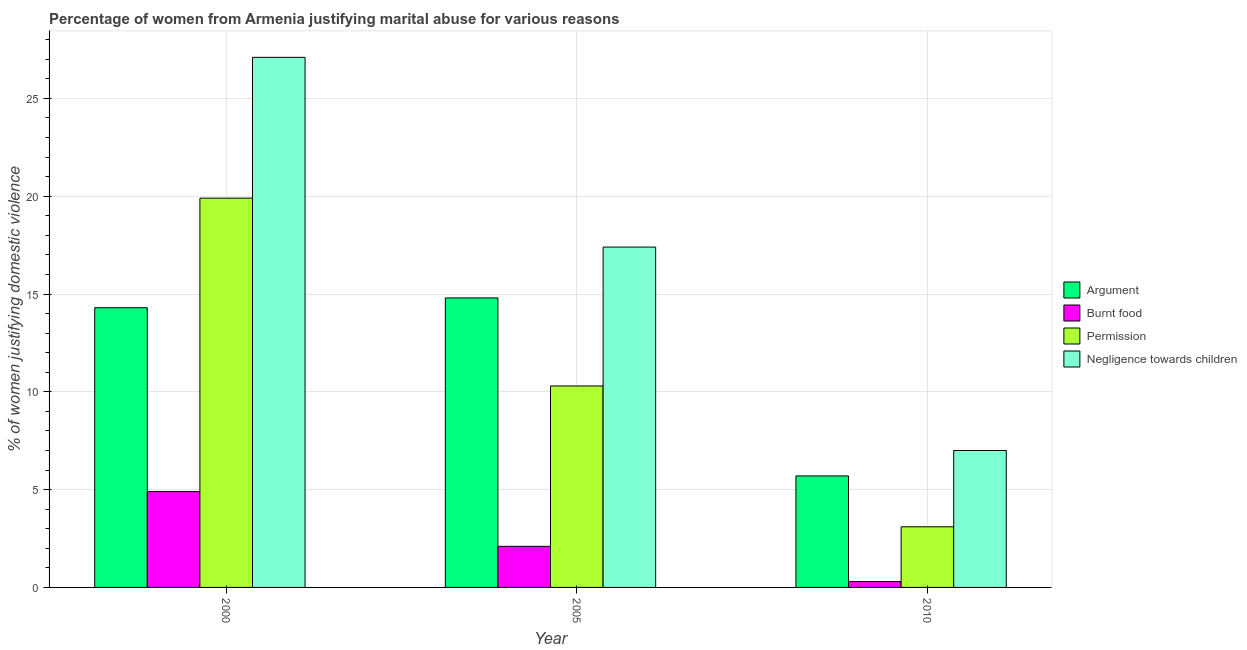How many groups of bars are there?
Your answer should be very brief. 3. Are the number of bars per tick equal to the number of legend labels?
Keep it short and to the point. Yes. Are the number of bars on each tick of the X-axis equal?
Provide a short and direct response. Yes. How many bars are there on the 3rd tick from the right?
Offer a terse response. 4. What is the label of the 3rd group of bars from the left?
Give a very brief answer. 2010. In how many cases, is the number of bars for a given year not equal to the number of legend labels?
Your answer should be compact. 0. What is the percentage of women justifying abuse for showing negligence towards children in 2000?
Your answer should be compact. 27.1. In which year was the percentage of women justifying abuse for burning food maximum?
Ensure brevity in your answer.  2000. What is the total percentage of women justifying abuse for burning food in the graph?
Ensure brevity in your answer.  7.3. What is the difference between the percentage of women justifying abuse for showing negligence towards children in 2005 and that in 2010?
Your answer should be very brief. 10.4. What is the difference between the percentage of women justifying abuse for showing negligence towards children in 2010 and the percentage of women justifying abuse for going without permission in 2000?
Offer a terse response. -20.1. What is the ratio of the percentage of women justifying abuse in the case of an argument in 2000 to that in 2010?
Offer a very short reply. 2.51. Is the percentage of women justifying abuse for burning food in 2005 less than that in 2010?
Offer a very short reply. No. Is the difference between the percentage of women justifying abuse for going without permission in 2000 and 2010 greater than the difference between the percentage of women justifying abuse in the case of an argument in 2000 and 2010?
Offer a very short reply. No. What is the difference between the highest and the second highest percentage of women justifying abuse for showing negligence towards children?
Give a very brief answer. 9.7. What is the difference between the highest and the lowest percentage of women justifying abuse in the case of an argument?
Give a very brief answer. 9.1. Is the sum of the percentage of women justifying abuse for burning food in 2000 and 2010 greater than the maximum percentage of women justifying abuse in the case of an argument across all years?
Offer a very short reply. Yes. What does the 4th bar from the left in 2010 represents?
Offer a very short reply. Negligence towards children. What does the 4th bar from the right in 2005 represents?
Give a very brief answer. Argument. How many bars are there?
Your answer should be very brief. 12. What is the difference between two consecutive major ticks on the Y-axis?
Offer a very short reply. 5. Where does the legend appear in the graph?
Offer a very short reply. Center right. How many legend labels are there?
Your answer should be very brief. 4. How are the legend labels stacked?
Your answer should be compact. Vertical. What is the title of the graph?
Keep it short and to the point. Percentage of women from Armenia justifying marital abuse for various reasons. What is the label or title of the Y-axis?
Offer a very short reply. % of women justifying domestic violence. What is the % of women justifying domestic violence of Permission in 2000?
Keep it short and to the point. 19.9. What is the % of women justifying domestic violence of Negligence towards children in 2000?
Provide a short and direct response. 27.1. What is the % of women justifying domestic violence in Permission in 2005?
Give a very brief answer. 10.3. What is the % of women justifying domestic violence in Negligence towards children in 2005?
Provide a succinct answer. 17.4. What is the % of women justifying domestic violence in Argument in 2010?
Your answer should be compact. 5.7. What is the % of women justifying domestic violence of Negligence towards children in 2010?
Provide a short and direct response. 7. Across all years, what is the maximum % of women justifying domestic violence of Argument?
Provide a short and direct response. 14.8. Across all years, what is the maximum % of women justifying domestic violence of Burnt food?
Keep it short and to the point. 4.9. Across all years, what is the maximum % of women justifying domestic violence in Permission?
Your answer should be very brief. 19.9. Across all years, what is the maximum % of women justifying domestic violence of Negligence towards children?
Provide a succinct answer. 27.1. Across all years, what is the minimum % of women justifying domestic violence in Negligence towards children?
Offer a very short reply. 7. What is the total % of women justifying domestic violence of Argument in the graph?
Make the answer very short. 34.8. What is the total % of women justifying domestic violence of Permission in the graph?
Your answer should be very brief. 33.3. What is the total % of women justifying domestic violence in Negligence towards children in the graph?
Offer a very short reply. 51.5. What is the difference between the % of women justifying domestic violence in Burnt food in 2000 and that in 2005?
Give a very brief answer. 2.8. What is the difference between the % of women justifying domestic violence in Negligence towards children in 2000 and that in 2005?
Ensure brevity in your answer.  9.7. What is the difference between the % of women justifying domestic violence of Permission in 2000 and that in 2010?
Offer a terse response. 16.8. What is the difference between the % of women justifying domestic violence of Negligence towards children in 2000 and that in 2010?
Offer a terse response. 20.1. What is the difference between the % of women justifying domestic violence of Argument in 2005 and that in 2010?
Offer a terse response. 9.1. What is the difference between the % of women justifying domestic violence in Negligence towards children in 2005 and that in 2010?
Provide a succinct answer. 10.4. What is the difference between the % of women justifying domestic violence of Argument in 2000 and the % of women justifying domestic violence of Negligence towards children in 2005?
Your answer should be very brief. -3.1. What is the difference between the % of women justifying domestic violence in Burnt food in 2000 and the % of women justifying domestic violence in Negligence towards children in 2005?
Give a very brief answer. -12.5. What is the difference between the % of women justifying domestic violence of Argument in 2000 and the % of women justifying domestic violence of Burnt food in 2010?
Make the answer very short. 14. What is the difference between the % of women justifying domestic violence in Burnt food in 2000 and the % of women justifying domestic violence in Permission in 2010?
Provide a short and direct response. 1.8. What is the difference between the % of women justifying domestic violence in Argument in 2005 and the % of women justifying domestic violence in Permission in 2010?
Ensure brevity in your answer.  11.7. What is the difference between the % of women justifying domestic violence in Argument in 2005 and the % of women justifying domestic violence in Negligence towards children in 2010?
Your answer should be compact. 7.8. What is the difference between the % of women justifying domestic violence of Burnt food in 2005 and the % of women justifying domestic violence of Negligence towards children in 2010?
Make the answer very short. -4.9. What is the average % of women justifying domestic violence of Burnt food per year?
Keep it short and to the point. 2.43. What is the average % of women justifying domestic violence of Negligence towards children per year?
Your response must be concise. 17.17. In the year 2000, what is the difference between the % of women justifying domestic violence of Argument and % of women justifying domestic violence of Burnt food?
Provide a succinct answer. 9.4. In the year 2000, what is the difference between the % of women justifying domestic violence of Argument and % of women justifying domestic violence of Permission?
Your answer should be very brief. -5.6. In the year 2000, what is the difference between the % of women justifying domestic violence of Argument and % of women justifying domestic violence of Negligence towards children?
Ensure brevity in your answer.  -12.8. In the year 2000, what is the difference between the % of women justifying domestic violence in Burnt food and % of women justifying domestic violence in Permission?
Offer a very short reply. -15. In the year 2000, what is the difference between the % of women justifying domestic violence of Burnt food and % of women justifying domestic violence of Negligence towards children?
Your answer should be compact. -22.2. In the year 2005, what is the difference between the % of women justifying domestic violence of Argument and % of women justifying domestic violence of Burnt food?
Ensure brevity in your answer.  12.7. In the year 2005, what is the difference between the % of women justifying domestic violence in Argument and % of women justifying domestic violence in Permission?
Make the answer very short. 4.5. In the year 2005, what is the difference between the % of women justifying domestic violence of Argument and % of women justifying domestic violence of Negligence towards children?
Offer a very short reply. -2.6. In the year 2005, what is the difference between the % of women justifying domestic violence of Burnt food and % of women justifying domestic violence of Permission?
Provide a succinct answer. -8.2. In the year 2005, what is the difference between the % of women justifying domestic violence in Burnt food and % of women justifying domestic violence in Negligence towards children?
Offer a very short reply. -15.3. In the year 2005, what is the difference between the % of women justifying domestic violence of Permission and % of women justifying domestic violence of Negligence towards children?
Your answer should be very brief. -7.1. In the year 2010, what is the difference between the % of women justifying domestic violence in Argument and % of women justifying domestic violence in Burnt food?
Provide a succinct answer. 5.4. In the year 2010, what is the difference between the % of women justifying domestic violence in Argument and % of women justifying domestic violence in Permission?
Give a very brief answer. 2.6. In the year 2010, what is the difference between the % of women justifying domestic violence of Argument and % of women justifying domestic violence of Negligence towards children?
Make the answer very short. -1.3. In the year 2010, what is the difference between the % of women justifying domestic violence in Burnt food and % of women justifying domestic violence in Permission?
Ensure brevity in your answer.  -2.8. What is the ratio of the % of women justifying domestic violence of Argument in 2000 to that in 2005?
Offer a very short reply. 0.97. What is the ratio of the % of women justifying domestic violence in Burnt food in 2000 to that in 2005?
Your answer should be compact. 2.33. What is the ratio of the % of women justifying domestic violence in Permission in 2000 to that in 2005?
Your answer should be very brief. 1.93. What is the ratio of the % of women justifying domestic violence of Negligence towards children in 2000 to that in 2005?
Your answer should be compact. 1.56. What is the ratio of the % of women justifying domestic violence in Argument in 2000 to that in 2010?
Ensure brevity in your answer.  2.51. What is the ratio of the % of women justifying domestic violence of Burnt food in 2000 to that in 2010?
Ensure brevity in your answer.  16.33. What is the ratio of the % of women justifying domestic violence in Permission in 2000 to that in 2010?
Make the answer very short. 6.42. What is the ratio of the % of women justifying domestic violence in Negligence towards children in 2000 to that in 2010?
Offer a very short reply. 3.87. What is the ratio of the % of women justifying domestic violence in Argument in 2005 to that in 2010?
Your answer should be very brief. 2.6. What is the ratio of the % of women justifying domestic violence of Permission in 2005 to that in 2010?
Offer a very short reply. 3.32. What is the ratio of the % of women justifying domestic violence of Negligence towards children in 2005 to that in 2010?
Your answer should be very brief. 2.49. What is the difference between the highest and the lowest % of women justifying domestic violence in Burnt food?
Offer a very short reply. 4.6. What is the difference between the highest and the lowest % of women justifying domestic violence in Permission?
Make the answer very short. 16.8. What is the difference between the highest and the lowest % of women justifying domestic violence of Negligence towards children?
Provide a short and direct response. 20.1. 